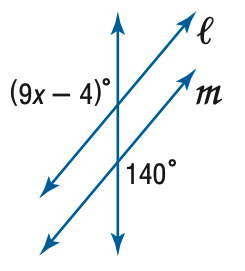Answer the mathemtical geometry problem and directly provide the correct option letter.
Question: Find x so that m \parallel n.
Choices: A: 13 B: 14 C: 15 D: 16 D 